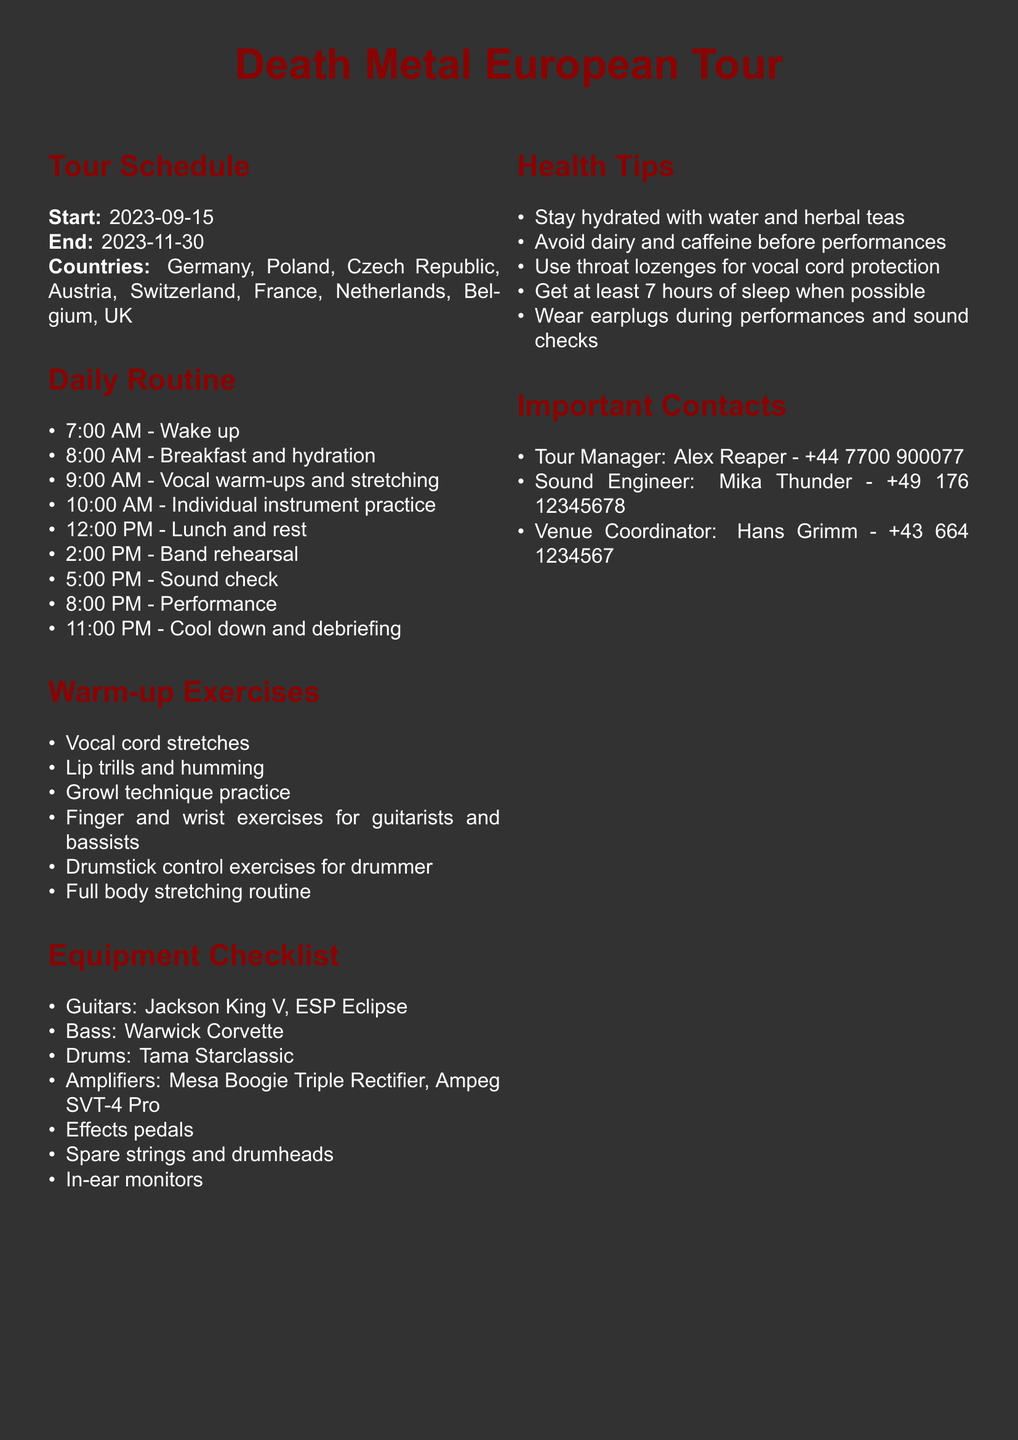What is the start date of the tour? The start date is clearly stated in the document under the tour schedule.
Answer: 2023-09-15 What is the end date of the tour? The end date is provided along with the start date in the tour schedule section.
Answer: 2023-11-30 Which countries are included in the tour? The countries are listed in the tour schedule section, which provides a complete list.
Answer: Germany, Poland, Czech Republic, Austria, Switzerland, France, Netherlands, Belgium, UK What time is the band rehearsal scheduled? The time for band rehearsal is specified in the daily routine section of the document.
Answer: 2:00 PM How many warm-up exercises are listed? The number of warm-up exercises can be counted from the warm-up exercises section.
Answer: 6 Who is the tour manager? The name of the tour manager is mentioned in the important contacts section.
Answer: Alex Reaper What should we avoid before performances? This information is outlined under health tips regarding things to avoid for better performance.
Answer: Dairy and caffeine What type of guitars are listed in the equipment checklist? The types of guitars are specified in the equipment checklist section.
Answer: Jackson King V, ESP Eclipse What is the recommended sleep duration? The health tips provide a specific recommendation regarding sleep duration.
Answer: 7 hours 